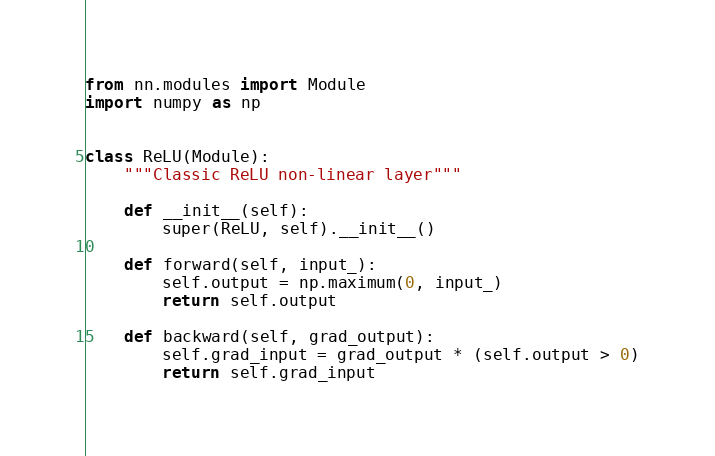<code> <loc_0><loc_0><loc_500><loc_500><_Python_>from nn.modules import Module
import numpy as np


class ReLU(Module):
    """Classic ReLU non-linear layer"""

    def __init__(self):
        super(ReLU, self).__init__()

    def forward(self, input_):
        self.output = np.maximum(0, input_)
        return self.output

    def backward(self, grad_output):
        self.grad_input = grad_output * (self.output > 0)
        return self.grad_input
</code> 